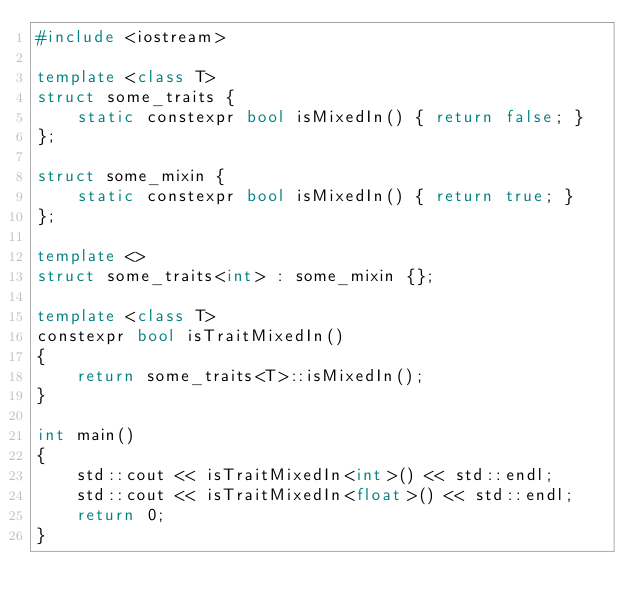<code> <loc_0><loc_0><loc_500><loc_500><_C++_>#include <iostream>

template <class T>
struct some_traits {
    static constexpr bool isMixedIn() { return false; }
};

struct some_mixin {
    static constexpr bool isMixedIn() { return true; }
};

template <>
struct some_traits<int> : some_mixin {};

template <class T>
constexpr bool isTraitMixedIn()
{
    return some_traits<T>::isMixedIn();
}

int main()
{
    std::cout << isTraitMixedIn<int>() << std::endl;
    std::cout << isTraitMixedIn<float>() << std::endl;
    return 0;
}
</code> 